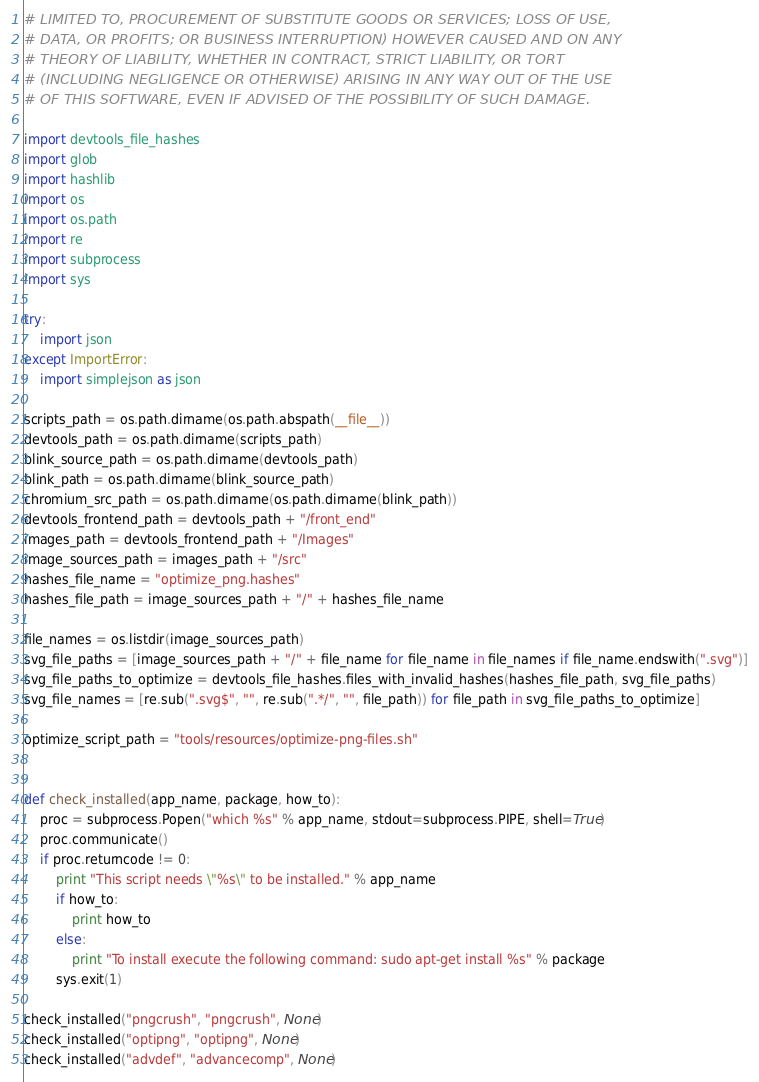Convert code to text. <code><loc_0><loc_0><loc_500><loc_500><_Python_># LIMITED TO, PROCUREMENT OF SUBSTITUTE GOODS OR SERVICES; LOSS OF USE,
# DATA, OR PROFITS; OR BUSINESS INTERRUPTION) HOWEVER CAUSED AND ON ANY
# THEORY OF LIABILITY, WHETHER IN CONTRACT, STRICT LIABILITY, OR TORT
# (INCLUDING NEGLIGENCE OR OTHERWISE) ARISING IN ANY WAY OUT OF THE USE
# OF THIS SOFTWARE, EVEN IF ADVISED OF THE POSSIBILITY OF SUCH DAMAGE.

import devtools_file_hashes
import glob
import hashlib
import os
import os.path
import re
import subprocess
import sys

try:
    import json
except ImportError:
    import simplejson as json

scripts_path = os.path.dirname(os.path.abspath(__file__))
devtools_path = os.path.dirname(scripts_path)
blink_source_path = os.path.dirname(devtools_path)
blink_path = os.path.dirname(blink_source_path)
chromium_src_path = os.path.dirname(os.path.dirname(blink_path))
devtools_frontend_path = devtools_path + "/front_end"
images_path = devtools_frontend_path + "/Images"
image_sources_path = images_path + "/src"
hashes_file_name = "optimize_png.hashes"
hashes_file_path = image_sources_path + "/" + hashes_file_name

file_names = os.listdir(image_sources_path)
svg_file_paths = [image_sources_path + "/" + file_name for file_name in file_names if file_name.endswith(".svg")]
svg_file_paths_to_optimize = devtools_file_hashes.files_with_invalid_hashes(hashes_file_path, svg_file_paths)
svg_file_names = [re.sub(".svg$", "", re.sub(".*/", "", file_path)) for file_path in svg_file_paths_to_optimize]

optimize_script_path = "tools/resources/optimize-png-files.sh"


def check_installed(app_name, package, how_to):
    proc = subprocess.Popen("which %s" % app_name, stdout=subprocess.PIPE, shell=True)
    proc.communicate()
    if proc.returncode != 0:
        print "This script needs \"%s\" to be installed." % app_name
        if how_to:
            print how_to
        else:
            print "To install execute the following command: sudo apt-get install %s" % package
        sys.exit(1)

check_installed("pngcrush", "pngcrush", None)
check_installed("optipng", "optipng", None)
check_installed("advdef", "advancecomp", None)</code> 